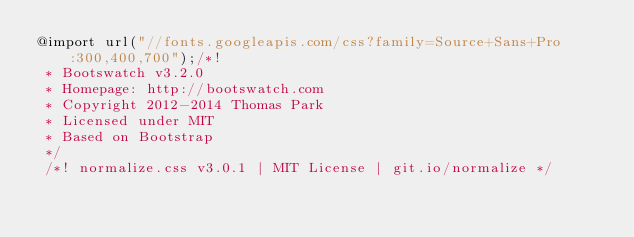Convert code to text. <code><loc_0><loc_0><loc_500><loc_500><_CSS_>@import url("//fonts.googleapis.com/css?family=Source+Sans+Pro:300,400,700");/*!
 * Bootswatch v3.2.0
 * Homepage: http://bootswatch.com
 * Copyright 2012-2014 Thomas Park
 * Licensed under MIT
 * Based on Bootstrap
 */
 /*! normalize.css v3.0.1 | MIT License | git.io/normalize */</code> 